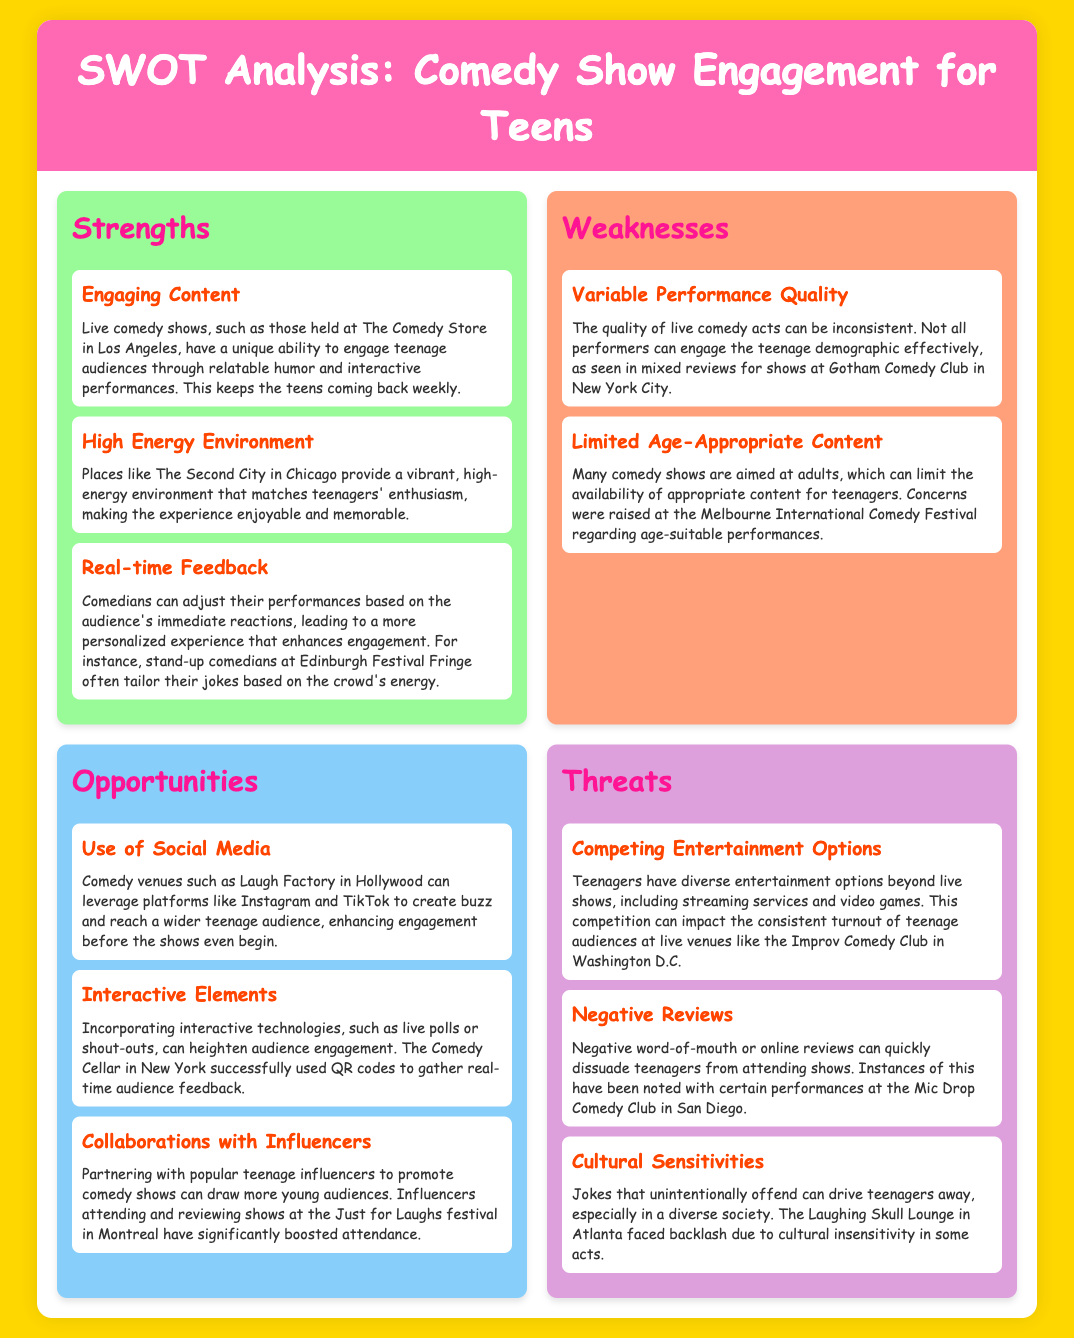what venue in Los Angeles is mentioned? The document references The Comedy Store in Los Angeles as a venue that engages teenage audiences.
Answer: The Comedy Store which city is highlighted for a vibrant, high-energy environment? The Second City in Chicago is noted for providing a vibrant, high-energy environment for teens.
Answer: Chicago what is one weakness related to comedy performance quality? The document states that the quality of live comedy acts can be inconsistent, affecting engagement.
Answer: Variable Performance Quality how can comedy venues reach a wider teenage audience? The document suggests using platforms like Instagram and TikTok to enhance engagement before shows.
Answer: Use of Social Media which festival is mentioned in connection with influencer attendance? The Just for Laughs festival in Montreal is noted for boosting attendance through influencers.
Answer: Just for Laughs what is a threat related to competing entertainment options? The competition from streaming services and video games is highlighted as a threat to live comedy shows.
Answer: Competing Entertainment Options how can comedians enhance audience engagement during performances? Comedians can adjust their performances based on the audience's immediate reactions as mentioned in the document.
Answer: Real-time Feedback what elements can be incorporated to heighten audience engagement? Incorporating live polls or shout-outs as interactive technologies can enhance audience engagement.
Answer: Interactive Elements what type of comedy shows may limit appropriate content for teens? Shows aimed at adults can limit the availability of suitable content for teenage audiences.
Answer: Limited Age-Appropriate Content 